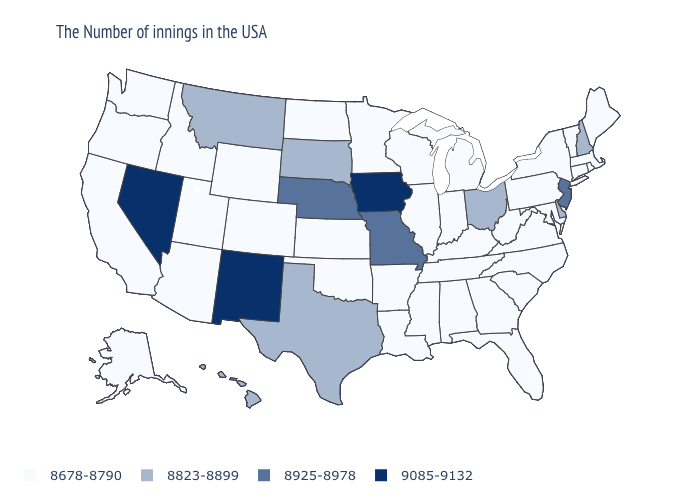What is the value of Mississippi?
Short answer required. 8678-8790. What is the value of Utah?
Quick response, please. 8678-8790. What is the value of Massachusetts?
Write a very short answer. 8678-8790. Which states have the lowest value in the USA?
Concise answer only. Maine, Massachusetts, Rhode Island, Vermont, Connecticut, New York, Maryland, Pennsylvania, Virginia, North Carolina, South Carolina, West Virginia, Florida, Georgia, Michigan, Kentucky, Indiana, Alabama, Tennessee, Wisconsin, Illinois, Mississippi, Louisiana, Arkansas, Minnesota, Kansas, Oklahoma, North Dakota, Wyoming, Colorado, Utah, Arizona, Idaho, California, Washington, Oregon, Alaska. Name the states that have a value in the range 8925-8978?
Keep it brief. New Jersey, Missouri, Nebraska. What is the value of West Virginia?
Write a very short answer. 8678-8790. What is the value of Massachusetts?
Concise answer only. 8678-8790. Name the states that have a value in the range 8678-8790?
Be succinct. Maine, Massachusetts, Rhode Island, Vermont, Connecticut, New York, Maryland, Pennsylvania, Virginia, North Carolina, South Carolina, West Virginia, Florida, Georgia, Michigan, Kentucky, Indiana, Alabama, Tennessee, Wisconsin, Illinois, Mississippi, Louisiana, Arkansas, Minnesota, Kansas, Oklahoma, North Dakota, Wyoming, Colorado, Utah, Arizona, Idaho, California, Washington, Oregon, Alaska. What is the highest value in the USA?
Keep it brief. 9085-9132. Name the states that have a value in the range 8823-8899?
Give a very brief answer. New Hampshire, Delaware, Ohio, Texas, South Dakota, Montana, Hawaii. Is the legend a continuous bar?
Answer briefly. No. What is the value of Texas?
Short answer required. 8823-8899. Name the states that have a value in the range 8823-8899?
Keep it brief. New Hampshire, Delaware, Ohio, Texas, South Dakota, Montana, Hawaii. 